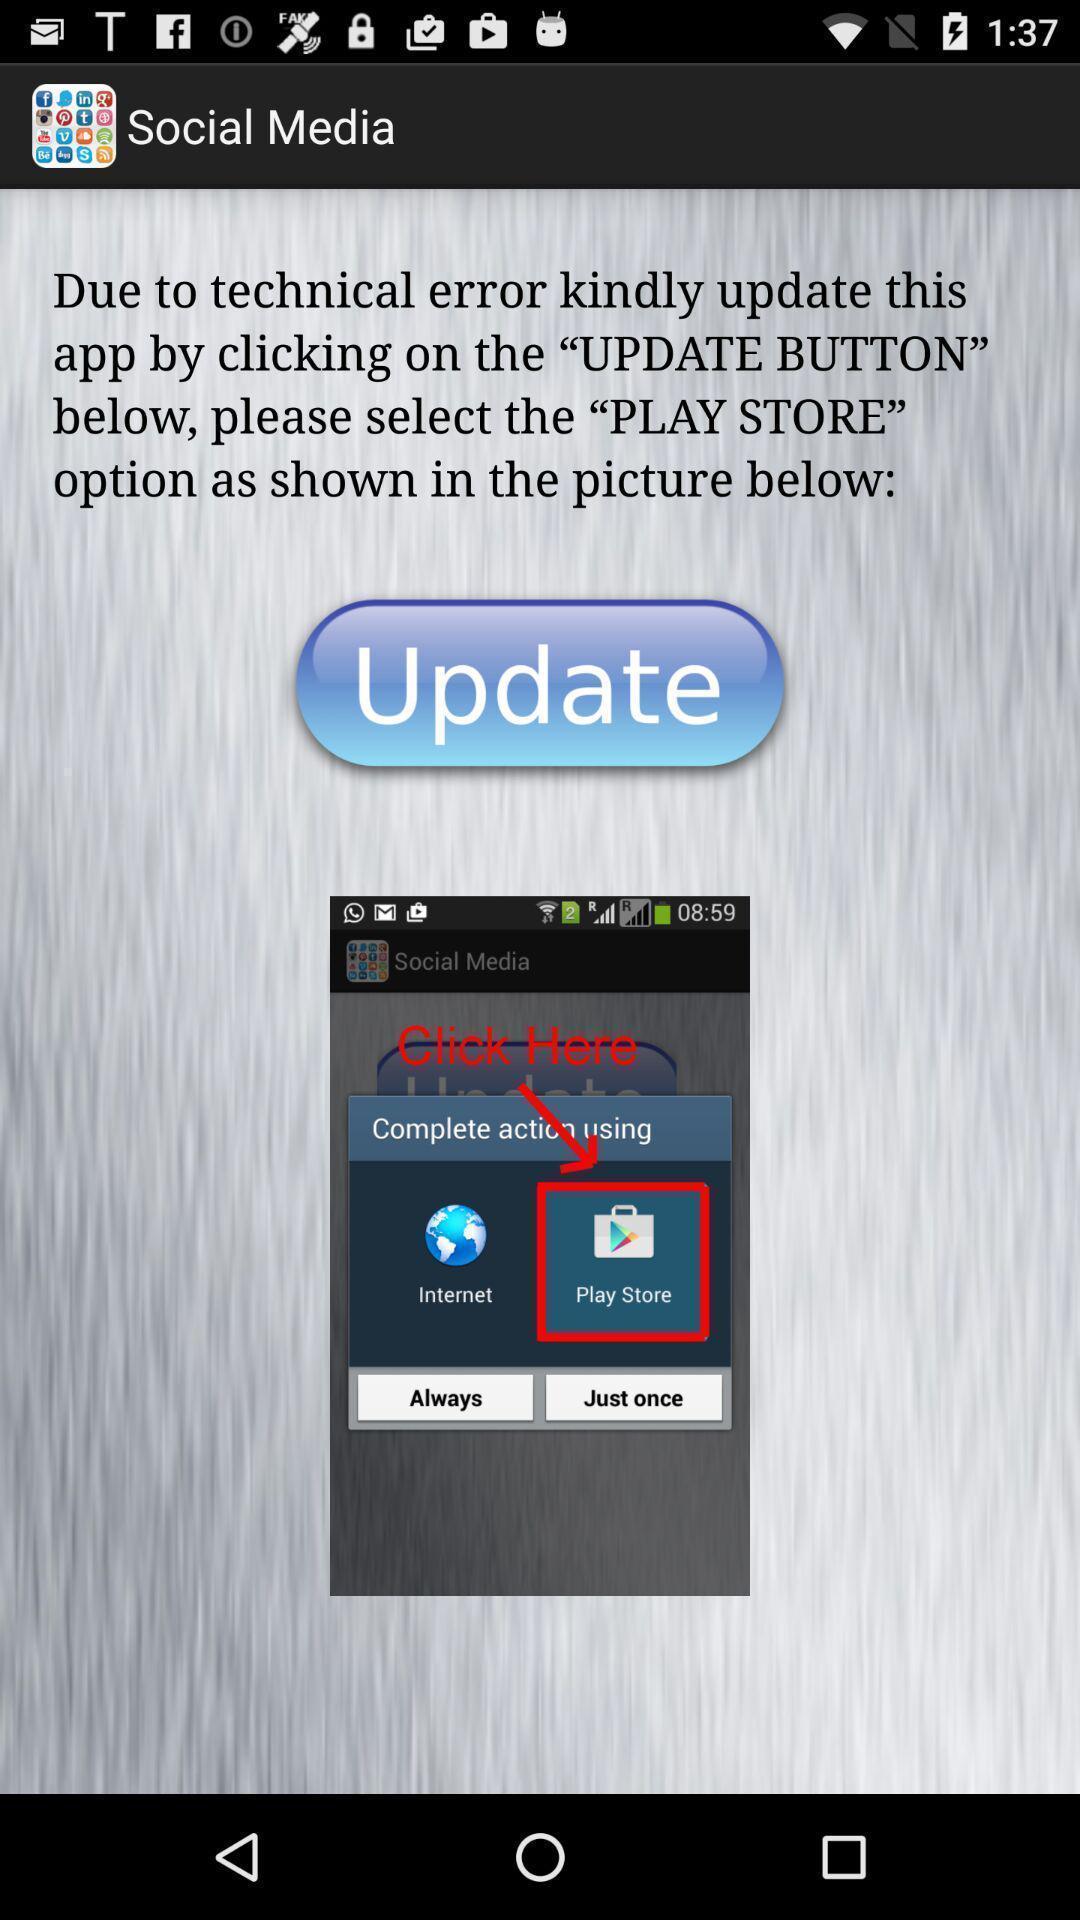Summarize the information in this screenshot. Pop up displaying to complete the action. 